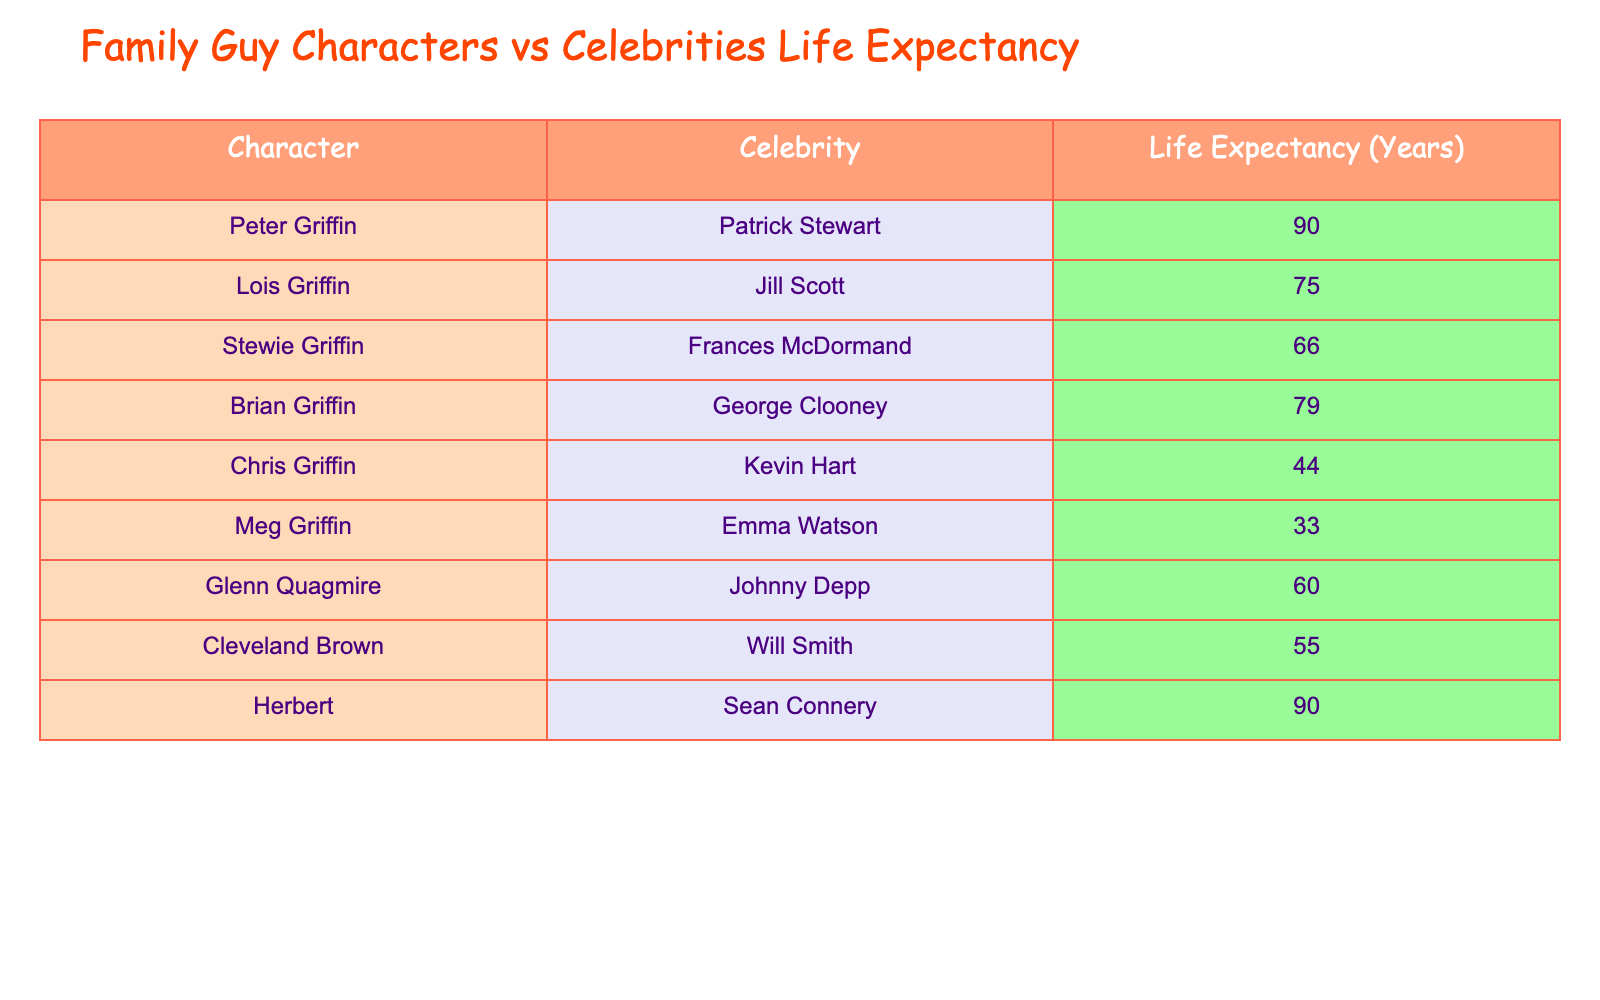What is the life expectancy of Peter Griffin? According to the table, Peter Griffin has a life expectancy of 90 years. This information can be found directly in the first row of the table.
Answer: 90 Who has a higher life expectancy, Lois Griffin or Jill Scott? From the table, Lois Griffin has a life expectancy of 75 years, while Jill Scott has a life expectancy of 75 years. Therefore, they have the same life expectancy.
Answer: They have the same life expectancy What is the life expectancy difference between Chris Griffin and Meg Griffin? Chris Griffin has a life expectancy of 44 years, while Meg Griffin has a life expectancy of 33 years. The difference is 44 - 33 = 11 years.
Answer: 11 years Are there any characters with a life expectancy above 80 years? In the table, both Peter Griffin and Herbert have life expectancies of 90 years, which is above 80 years. Therefore, the answer is yes.
Answer: Yes What is the average life expectancy of the Family Guy characters listed in the table? The life expectancies of the Family Guy characters are 90, 75, 66, 79, 44, 33, 60, and 55. Adding these gives 90 + 75 + 66 + 79 + 44 + 33 + 60 + 55 = 502. There are 8 characters, so the average is 502 / 8 = 62.75.
Answer: 62.75 Which celebrity has the lowest life expectancy in the table? Looking through the table, Meg Griffin corresponds with Emma Watson, who has the lowest life expectancy at 33 years. This can be determined by comparing the values.
Answer: Emma Watson Who has a higher life expectancy, Brian Griffin or George Clooney? According to the table, Brian Griffin has a life expectancy of 79 years and George Clooney has a life expectancy of 79 years. Therefore, they have the same life expectancy.
Answer: They have the same life expectancy How many characters have a life expectancy less than 60 years? In the table, Chris Griffin (44), Meg Griffin (33), Glenn Quagmire (60), and Cleveland Brown (55) have life expectancies below 60 years. This results in a count of 3 characters: Chris, Meg, and Cleveland.
Answer: 3 characters Is the life expectancy of Glenn Quagmire greater than that of Brian Griffin? Glenn Quagmire has a life expectancy of 60 years, while Brian Griffin has a life expectancy of 79 years. Therefore, Glenn Quagmire does not have a greater life expectancy than Brian Griffin.
Answer: No 